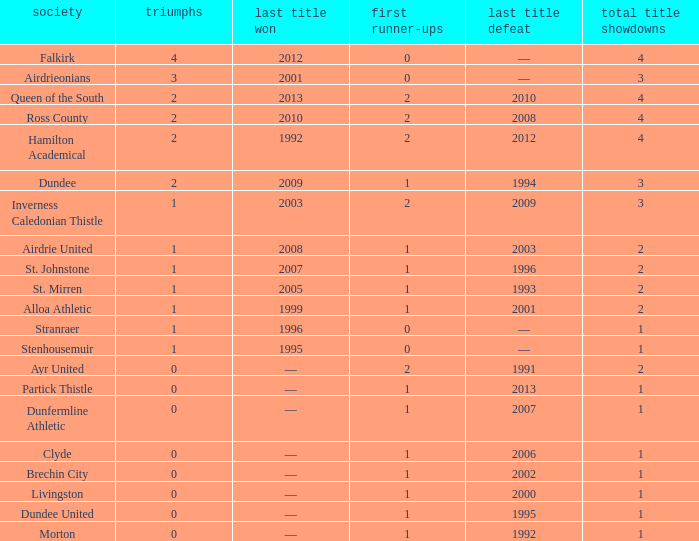How manywins for dunfermline athletic that has a total final appearances less than 2? 0.0. 